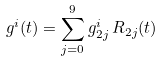<formula> <loc_0><loc_0><loc_500><loc_500>g ^ { i } ( t ) = \sum _ { j = 0 } ^ { 9 } g ^ { i } _ { 2 j } \, R _ { 2 j } ( t )</formula> 